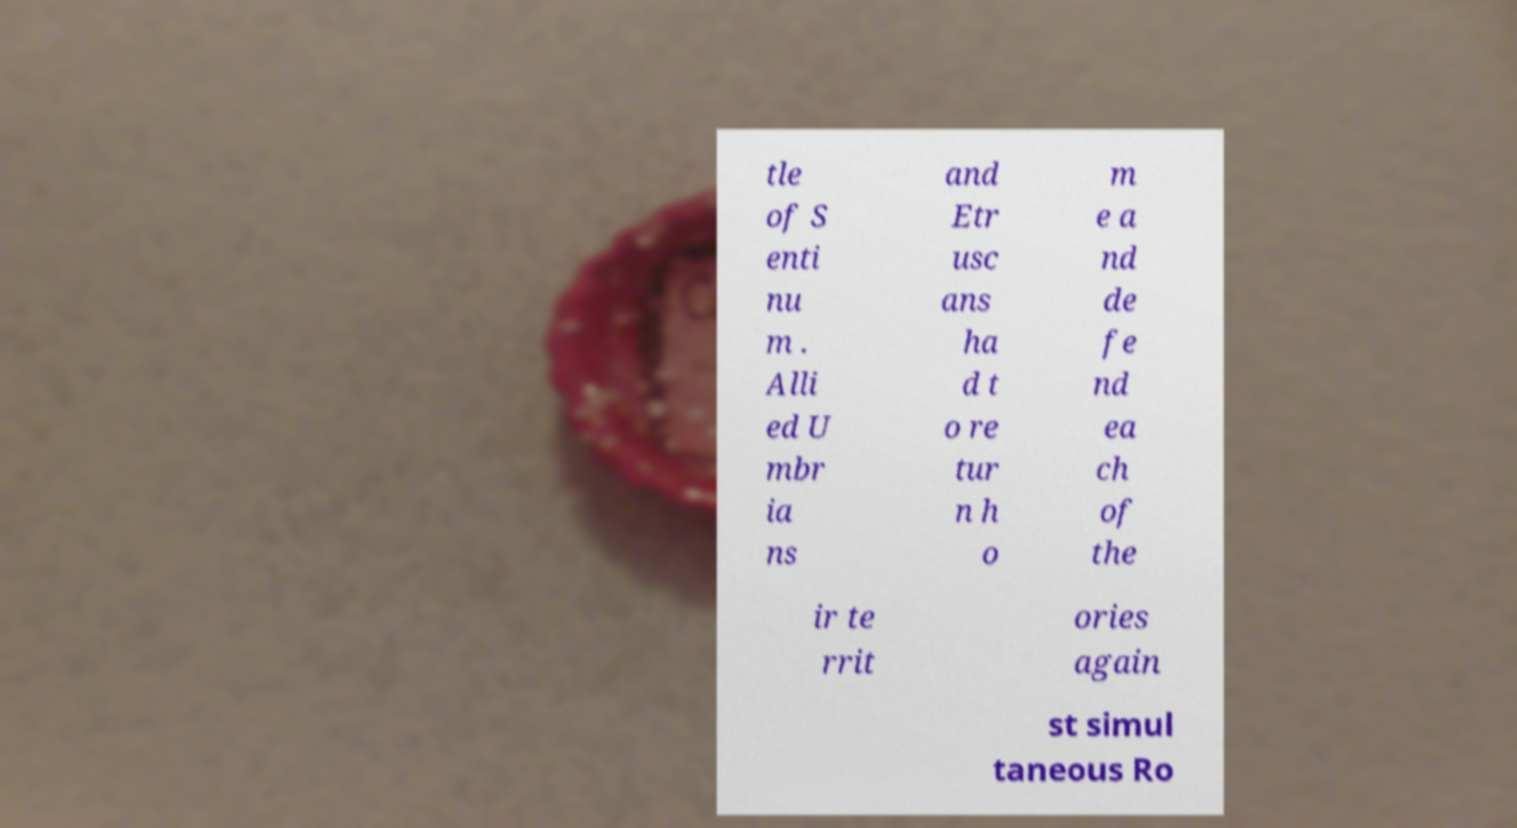Please read and relay the text visible in this image. What does it say? tle of S enti nu m . Alli ed U mbr ia ns and Etr usc ans ha d t o re tur n h o m e a nd de fe nd ea ch of the ir te rrit ories again st simul taneous Ro 